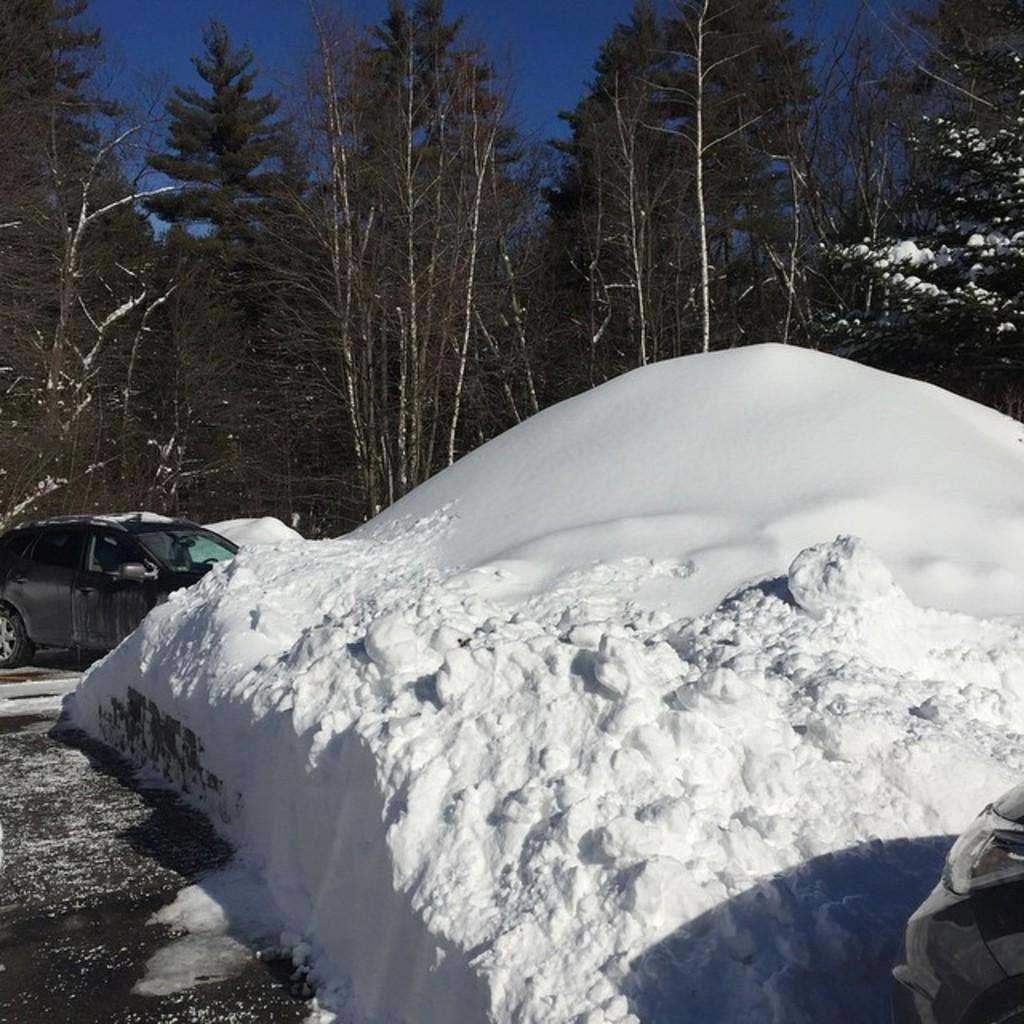What is the main feature of the image? There is a snow hill in the image. Where is the snow hill located? The snow hill is on a path. What other objects or structures can be seen in the image? There is a black car in the image, and it is beside the snow hill. What type of natural elements are visible in the image? Trees and the sky are visible in the image. How many pets are visible in the image? There are no pets present in the image. What type of credit card is being used to purchase the snow hill in the image? There is no credit card or purchase involved in the image; it is a snow hill on a path. 